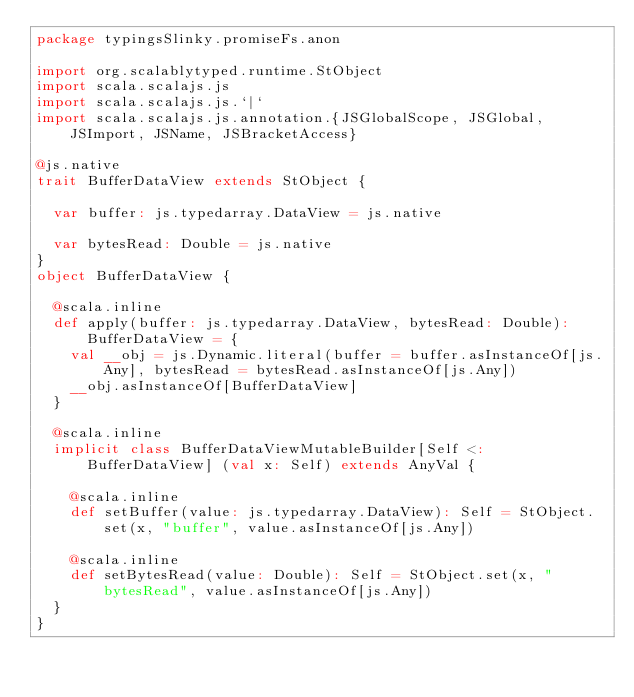Convert code to text. <code><loc_0><loc_0><loc_500><loc_500><_Scala_>package typingsSlinky.promiseFs.anon

import org.scalablytyped.runtime.StObject
import scala.scalajs.js
import scala.scalajs.js.`|`
import scala.scalajs.js.annotation.{JSGlobalScope, JSGlobal, JSImport, JSName, JSBracketAccess}

@js.native
trait BufferDataView extends StObject {
  
  var buffer: js.typedarray.DataView = js.native
  
  var bytesRead: Double = js.native
}
object BufferDataView {
  
  @scala.inline
  def apply(buffer: js.typedarray.DataView, bytesRead: Double): BufferDataView = {
    val __obj = js.Dynamic.literal(buffer = buffer.asInstanceOf[js.Any], bytesRead = bytesRead.asInstanceOf[js.Any])
    __obj.asInstanceOf[BufferDataView]
  }
  
  @scala.inline
  implicit class BufferDataViewMutableBuilder[Self <: BufferDataView] (val x: Self) extends AnyVal {
    
    @scala.inline
    def setBuffer(value: js.typedarray.DataView): Self = StObject.set(x, "buffer", value.asInstanceOf[js.Any])
    
    @scala.inline
    def setBytesRead(value: Double): Self = StObject.set(x, "bytesRead", value.asInstanceOf[js.Any])
  }
}
</code> 